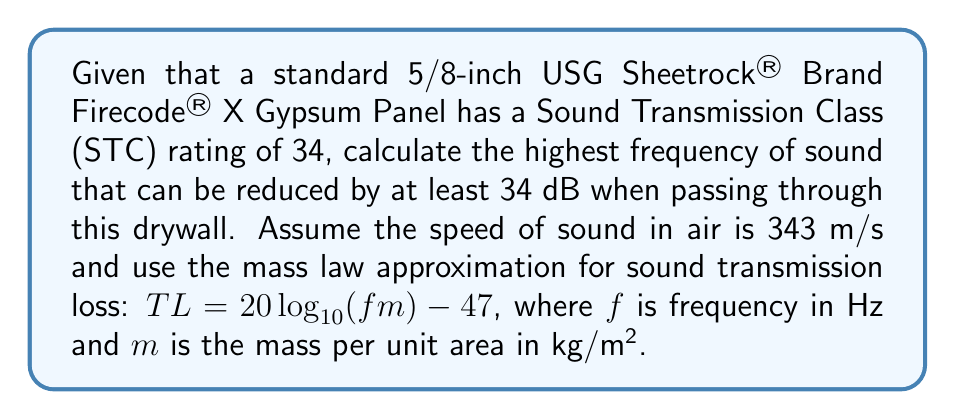Help me with this question. To solve this problem, we'll follow these steps:

1) First, we need to determine the mass per unit area ($m$) of the drywall:
   5/8-inch USG Sheetrock® Brand Firecode® X Gypsum Panel typically weighs about 2.2 lb/ft².
   Converting to kg/m²: $m = 2.2 \text{ lb/ft²} \times 4.88 \text{ kg/m²/lb/ft²} = 10.736 \text{ kg/m²}$

2) We want to find the frequency where the Transmission Loss (TL) equals the STC rating of 34:
   $34 = 20 \log_{10}(f \times 10.736) - 47$

3) Solving for $f$:
   $81 = 20 \log_{10}(f \times 10.736)$
   $4.05 = \log_{10}(f \times 10.736)$
   $10^{4.05} = f \times 10.736$
   $f = \frac{10^{4.05}}{10.736} \approx 10,453 \text{ Hz}$

4) To verify, we can check if this frequency results in a 34 dB reduction:
   $TL = 20 \log_{10}(10453 \times 10.736) - 47 \approx 34 \text{ dB}$

5) Therefore, frequencies up to approximately 10,453 Hz will be reduced by at least 34 dB.
Answer: 10,453 Hz 